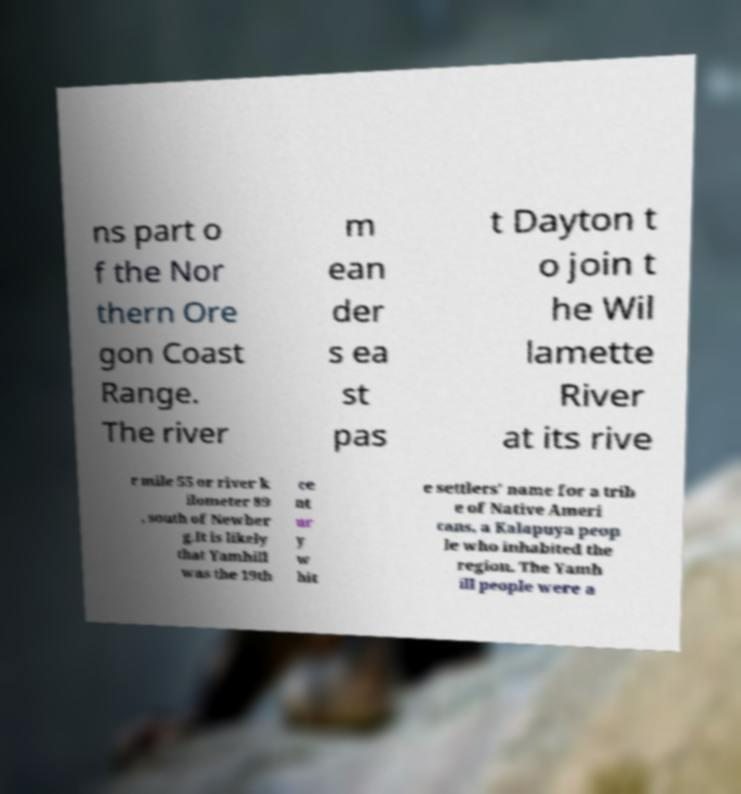Could you assist in decoding the text presented in this image and type it out clearly? ns part o f the Nor thern Ore gon Coast Range. The river m ean der s ea st pas t Dayton t o join t he Wil lamette River at its rive r mile 55 or river k ilometer 89 , south of Newber g.It is likely that Yamhill was the 19th ce nt ur y w hit e settlers' name for a trib e of Native Ameri cans, a Kalapuya peop le who inhabited the region. The Yamh ill people were a 